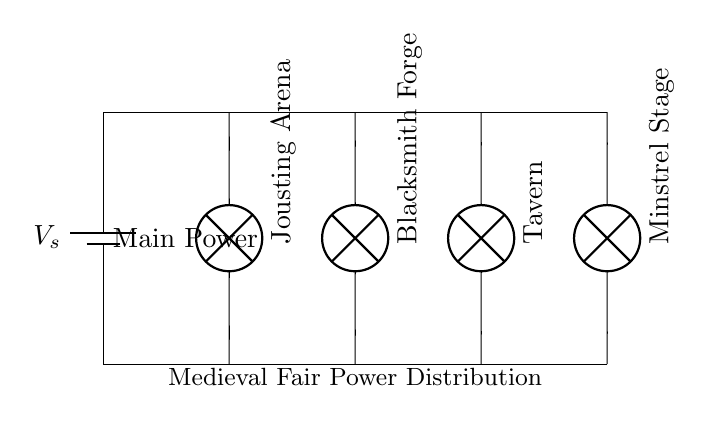What is the main power source in this circuit? The main power source is indicated as a battery, labeled V_s. This is usually where the electrical energy originates before being distributed to the various components in a circuit.
Answer: Battery How many parallel branches are there? By counting the individual branches leading off the main distribution line, we can see there are four branches: Jousting Arena, Blacksmith Forge, Tavern, and Minstrel Stage. Each branch operates independently from the others in a parallel configuration.
Answer: Four What do the lamps represent? The lamps in this circuit diagram represent different attractions at the medieval fair: Jousting Arena, Blacksmith Forge, Tavern, and Minstrel Stage. Each lamp indicates where the electrical power is used for lighting.
Answer: Various attractions Which attraction is connected to the second parallel branch? The second parallel branch is connected to the Blacksmith Forge, as indicated by the lamp associated with that branch. This shows what specific component or area receives power from this branch.
Answer: Blacksmith Forge How does a parallel distribution affect power availability? In a parallel circuit, each component receives the same voltage. This means that if one branch goes out, the others remain unaffected and continue to receive power, ensuring consistent operation for all attractions at the fair.
Answer: Consistent operation What is the overall purpose of this circuit diagram? The overall purpose of the circuit diagram is to illustrate how electrical power is distributed among multiple attractions at a medieval fair. It shows the main power source and how that power is channeled to different parts of the event.
Answer: Power distribution 